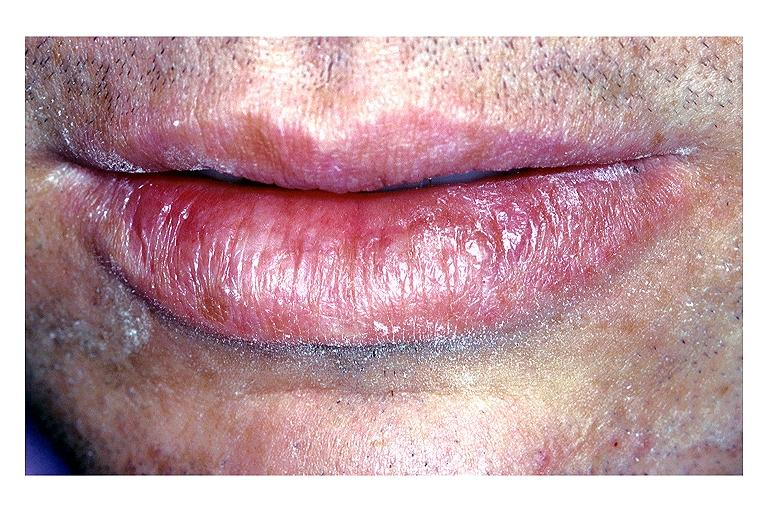what does this image show?
Answer the question using a single word or phrase. Actinic keratosis 